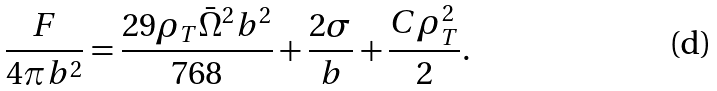<formula> <loc_0><loc_0><loc_500><loc_500>\frac { F } { 4 \pi b ^ { 2 } } = \frac { 2 9 \rho _ { T } \bar { \Omega } ^ { 2 } b ^ { 2 } } { 7 6 8 } + \frac { 2 \sigma } { b } + \frac { C \rho _ { T } ^ { 2 } } { 2 } .</formula> 